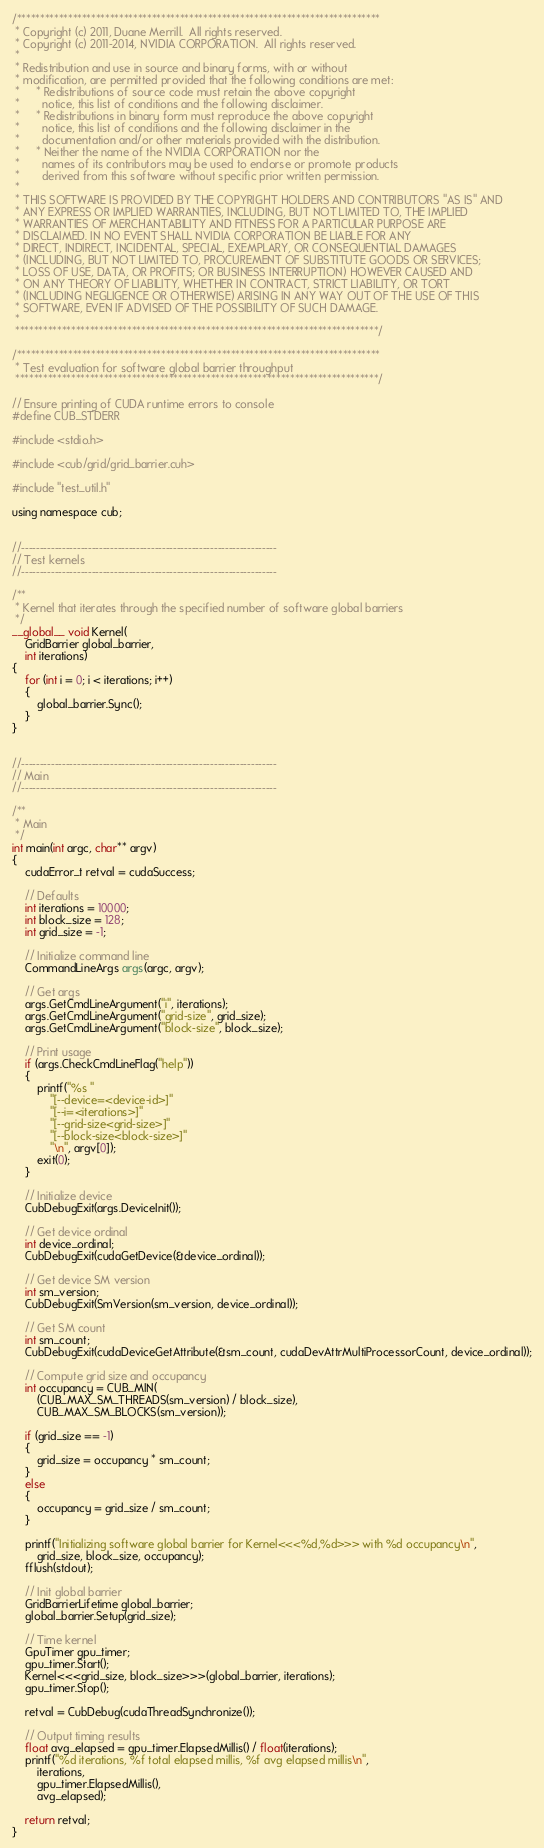<code> <loc_0><loc_0><loc_500><loc_500><_Cuda_>/******************************************************************************
 * Copyright (c) 2011, Duane Merrill.  All rights reserved.
 * Copyright (c) 2011-2014, NVIDIA CORPORATION.  All rights reserved.
 *
 * Redistribution and use in source and binary forms, with or without
 * modification, are permitted provided that the following conditions are met:
 *     * Redistributions of source code must retain the above copyright
 *       notice, this list of conditions and the following disclaimer.
 *     * Redistributions in binary form must reproduce the above copyright
 *       notice, this list of conditions and the following disclaimer in the
 *       documentation and/or other materials provided with the distribution.
 *     * Neither the name of the NVIDIA CORPORATION nor the
 *       names of its contributors may be used to endorse or promote products
 *       derived from this software without specific prior written permission.
 *
 * THIS SOFTWARE IS PROVIDED BY THE COPYRIGHT HOLDERS AND CONTRIBUTORS "AS IS" AND
 * ANY EXPRESS OR IMPLIED WARRANTIES, INCLUDING, BUT NOT LIMITED TO, THE IMPLIED
 * WARRANTIES OF MERCHANTABILITY AND FITNESS FOR A PARTICULAR PURPOSE ARE
 * DISCLAIMED. IN NO EVENT SHALL NVIDIA CORPORATION BE LIABLE FOR ANY
 * DIRECT, INDIRECT, INCIDENTAL, SPECIAL, EXEMPLARY, OR CONSEQUENTIAL DAMAGES
 * (INCLUDING, BUT NOT LIMITED TO, PROCUREMENT OF SUBSTITUTE GOODS OR SERVICES;
 * LOSS OF USE, DATA, OR PROFITS; OR BUSINESS INTERRUPTION) HOWEVER CAUSED AND
 * ON ANY THEORY OF LIABILITY, WHETHER IN CONTRACT, STRICT LIABILITY, OR TORT
 * (INCLUDING NEGLIGENCE OR OTHERWISE) ARISING IN ANY WAY OUT OF THE USE OF THIS
 * SOFTWARE, EVEN IF ADVISED OF THE POSSIBILITY OF SUCH DAMAGE.
 *
 ******************************************************************************/

/******************************************************************************
 * Test evaluation for software global barrier throughput
 ******************************************************************************/

// Ensure printing of CUDA runtime errors to console
#define CUB_STDERR

#include <stdio.h>

#include <cub/grid/grid_barrier.cuh>

#include "test_util.h"

using namespace cub;


//---------------------------------------------------------------------
// Test kernels
//---------------------------------------------------------------------

/**
 * Kernel that iterates through the specified number of software global barriers
 */
__global__ void Kernel(
    GridBarrier global_barrier,
    int iterations)
{
    for (int i = 0; i < iterations; i++)
    {
        global_barrier.Sync();
    }
}


//---------------------------------------------------------------------
// Main
//---------------------------------------------------------------------

/**
 * Main
 */
int main(int argc, char** argv)
{
    cudaError_t retval = cudaSuccess;

    // Defaults
    int iterations = 10000;
    int block_size = 128;
    int grid_size = -1;

    // Initialize command line
    CommandLineArgs args(argc, argv);

    // Get args
    args.GetCmdLineArgument("i", iterations);
    args.GetCmdLineArgument("grid-size", grid_size);
    args.GetCmdLineArgument("block-size", block_size);

    // Print usage
    if (args.CheckCmdLineFlag("help"))
    {
        printf("%s "
            "[--device=<device-id>]"
            "[--i=<iterations>]"
            "[--grid-size<grid-size>]"
            "[--block-size<block-size>]"
            "\n", argv[0]);
        exit(0);
    }

    // Initialize device
    CubDebugExit(args.DeviceInit());

    // Get device ordinal
    int device_ordinal;
    CubDebugExit(cudaGetDevice(&device_ordinal));

    // Get device SM version
    int sm_version;
    CubDebugExit(SmVersion(sm_version, device_ordinal));

    // Get SM count
    int sm_count;
    CubDebugExit(cudaDeviceGetAttribute(&sm_count, cudaDevAttrMultiProcessorCount, device_ordinal));

    // Compute grid size and occupancy
    int occupancy = CUB_MIN(
        (CUB_MAX_SM_THREADS(sm_version) / block_size),
        CUB_MAX_SM_BLOCKS(sm_version));

    if (grid_size == -1)
    {
        grid_size = occupancy * sm_count;
    }
    else
    {
        occupancy = grid_size / sm_count;
    }

    printf("Initializing software global barrier for Kernel<<<%d,%d>>> with %d occupancy\n",
        grid_size, block_size, occupancy);
    fflush(stdout);

    // Init global barrier
    GridBarrierLifetime global_barrier;
    global_barrier.Setup(grid_size);

    // Time kernel
    GpuTimer gpu_timer;
    gpu_timer.Start();
    Kernel<<<grid_size, block_size>>>(global_barrier, iterations);
    gpu_timer.Stop();

    retval = CubDebug(cudaThreadSynchronize());

    // Output timing results
    float avg_elapsed = gpu_timer.ElapsedMillis() / float(iterations);
    printf("%d iterations, %f total elapsed millis, %f avg elapsed millis\n",
        iterations,
        gpu_timer.ElapsedMillis(),
        avg_elapsed);

    return retval;
}
</code> 